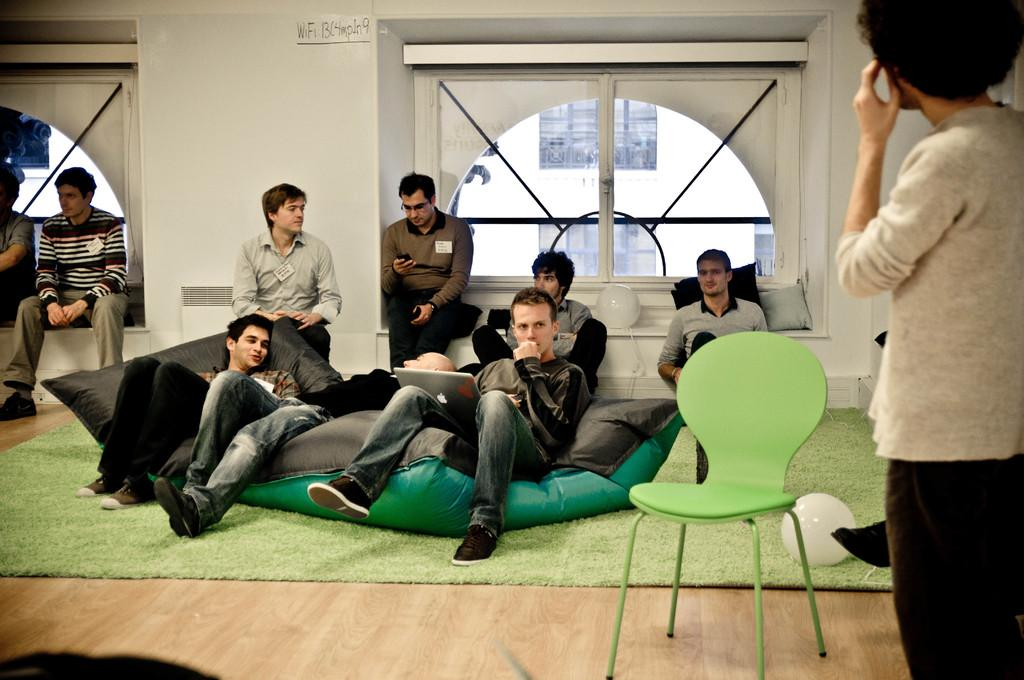How many people are in the image? There are people in the image, but the exact number is not specified. What are the people in the image doing? One person is standing, while others are sitting. What type of furniture is present in the image? There is a chair in the image. What electronic device can be seen in the image? There is a laptop in the image. What type of soft furnishings are present in the image? There are cushions in the image. What type of army is depicted in the image? There is no army present in the image. Can you describe the scarecrow in the image? There is no scarecrow present in the image. 